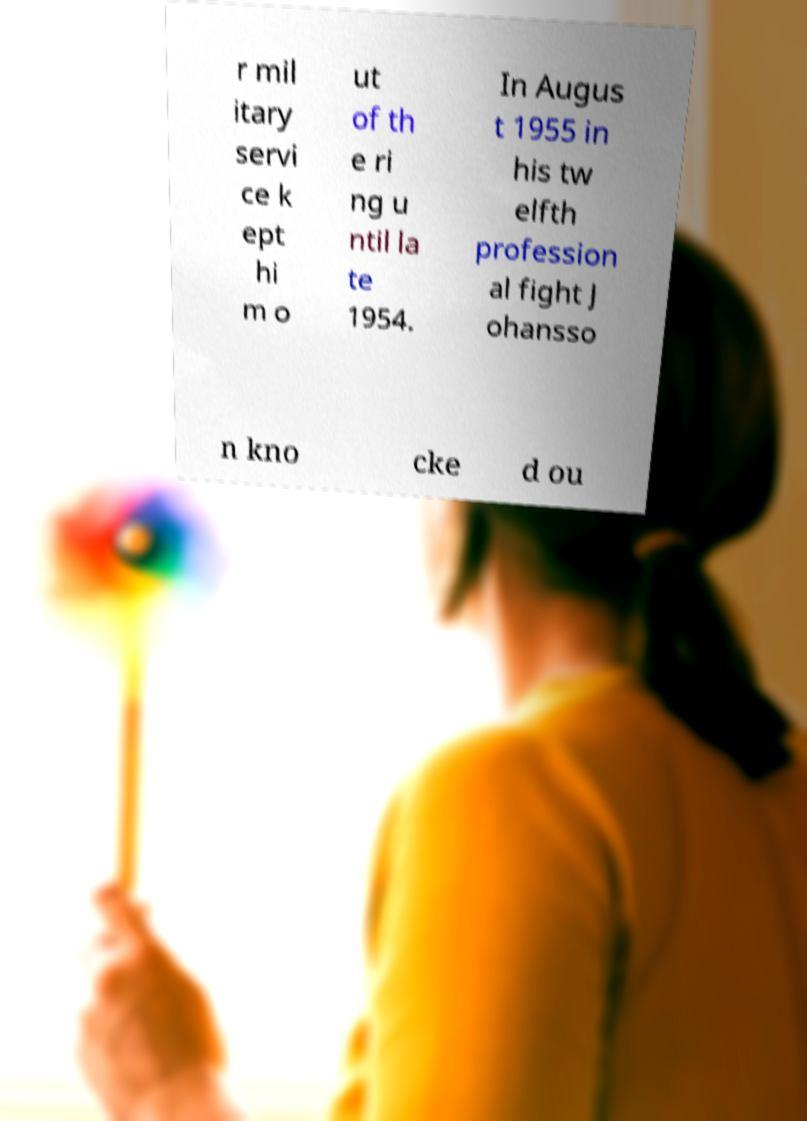Could you assist in decoding the text presented in this image and type it out clearly? r mil itary servi ce k ept hi m o ut of th e ri ng u ntil la te 1954. In Augus t 1955 in his tw elfth profession al fight J ohansso n kno cke d ou 